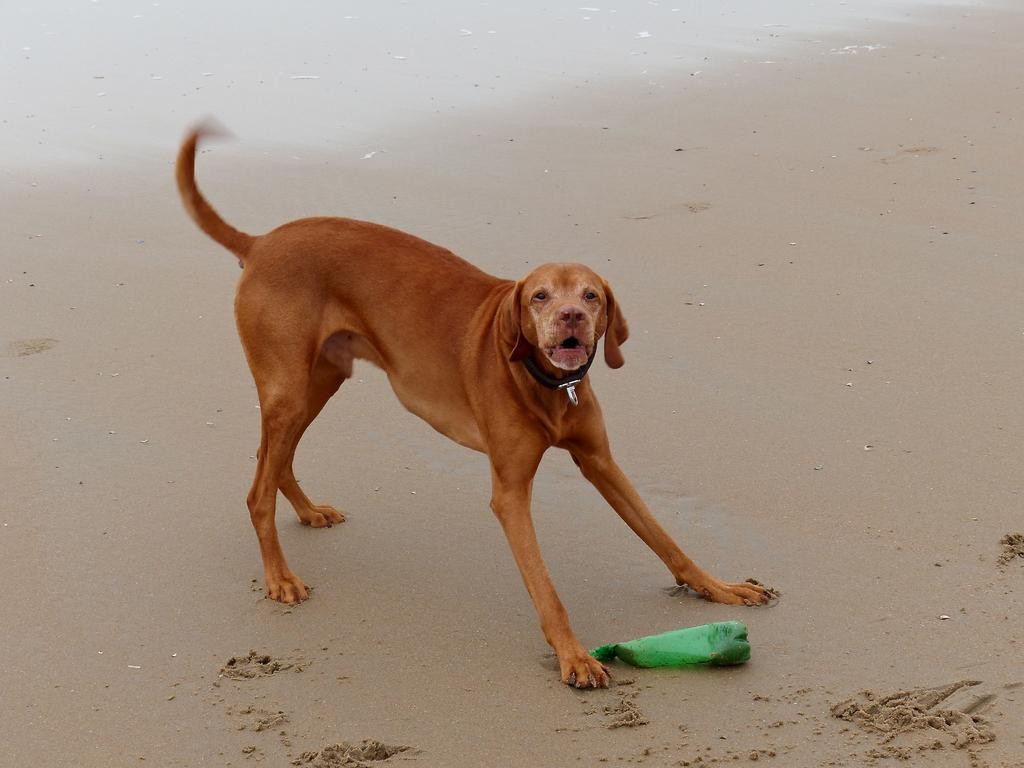What type of animal is in the image? There is a dog in the image. Where is the dog located? The dog is on the sea shore. What other object can be seen in the image? There is a bottle in the image. Where is the bottle located? The bottle is on the sand. What type of suit is the dog wearing in the image? There is no suit present in the image, and the dog is not wearing any clothing. 